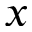Convert formula to latex. <formula><loc_0><loc_0><loc_500><loc_500>x</formula> 